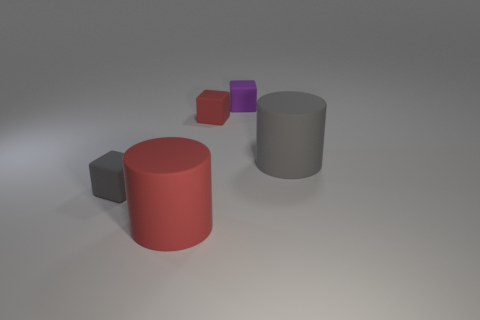Subtract all purple matte cubes. How many cubes are left? 2 Subtract 2 cubes. How many cubes are left? 1 Add 4 tiny red matte cubes. How many objects exist? 9 Subtract all purple cubes. How many cubes are left? 2 Subtract all cubes. How many objects are left? 2 Add 4 matte cubes. How many matte cubes are left? 7 Add 3 small brown balls. How many small brown balls exist? 3 Subtract 0 cyan balls. How many objects are left? 5 Subtract all cyan cubes. Subtract all green cylinders. How many cubes are left? 3 Subtract all small red objects. Subtract all big gray matte balls. How many objects are left? 4 